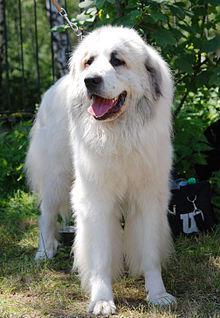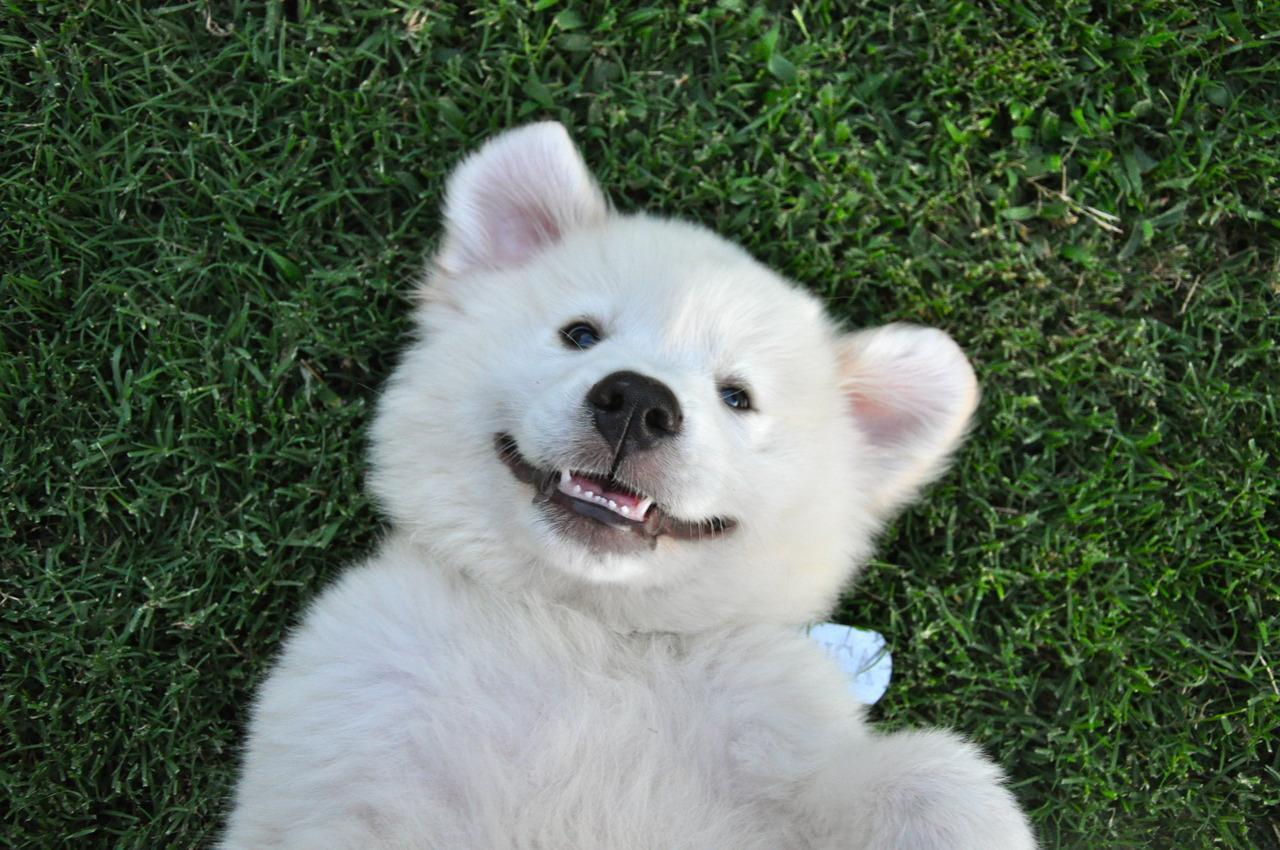The first image is the image on the left, the second image is the image on the right. Analyze the images presented: Is the assertion "At least one of the dogs has its tongue sticking out." valid? Answer yes or no. Yes. The first image is the image on the left, the second image is the image on the right. Assess this claim about the two images: "There are two dogs". Correct or not? Answer yes or no. Yes. The first image is the image on the left, the second image is the image on the right. Evaluate the accuracy of this statement regarding the images: "Left image shows a dog standing in profile with body turned leftward.". Is it true? Answer yes or no. No. 